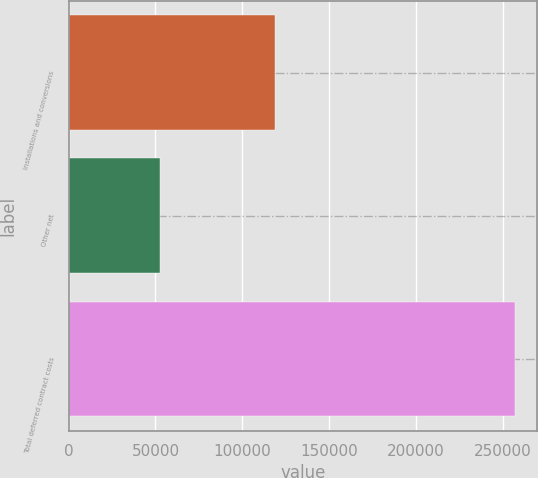<chart> <loc_0><loc_0><loc_500><loc_500><bar_chart><fcel>Installations and conversions<fcel>Other net<fcel>Total deferred contract costs<nl><fcel>118787<fcel>52606<fcel>256852<nl></chart> 